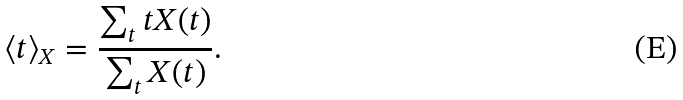<formula> <loc_0><loc_0><loc_500><loc_500>\langle t \rangle _ { X } = \frac { \sum _ { t } t X ( t ) } { \sum _ { t } X ( t ) } .</formula> 